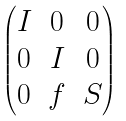<formula> <loc_0><loc_0><loc_500><loc_500>\begin{pmatrix} I & 0 & 0 \\ 0 & I & 0 \\ 0 & f & S \end{pmatrix}</formula> 